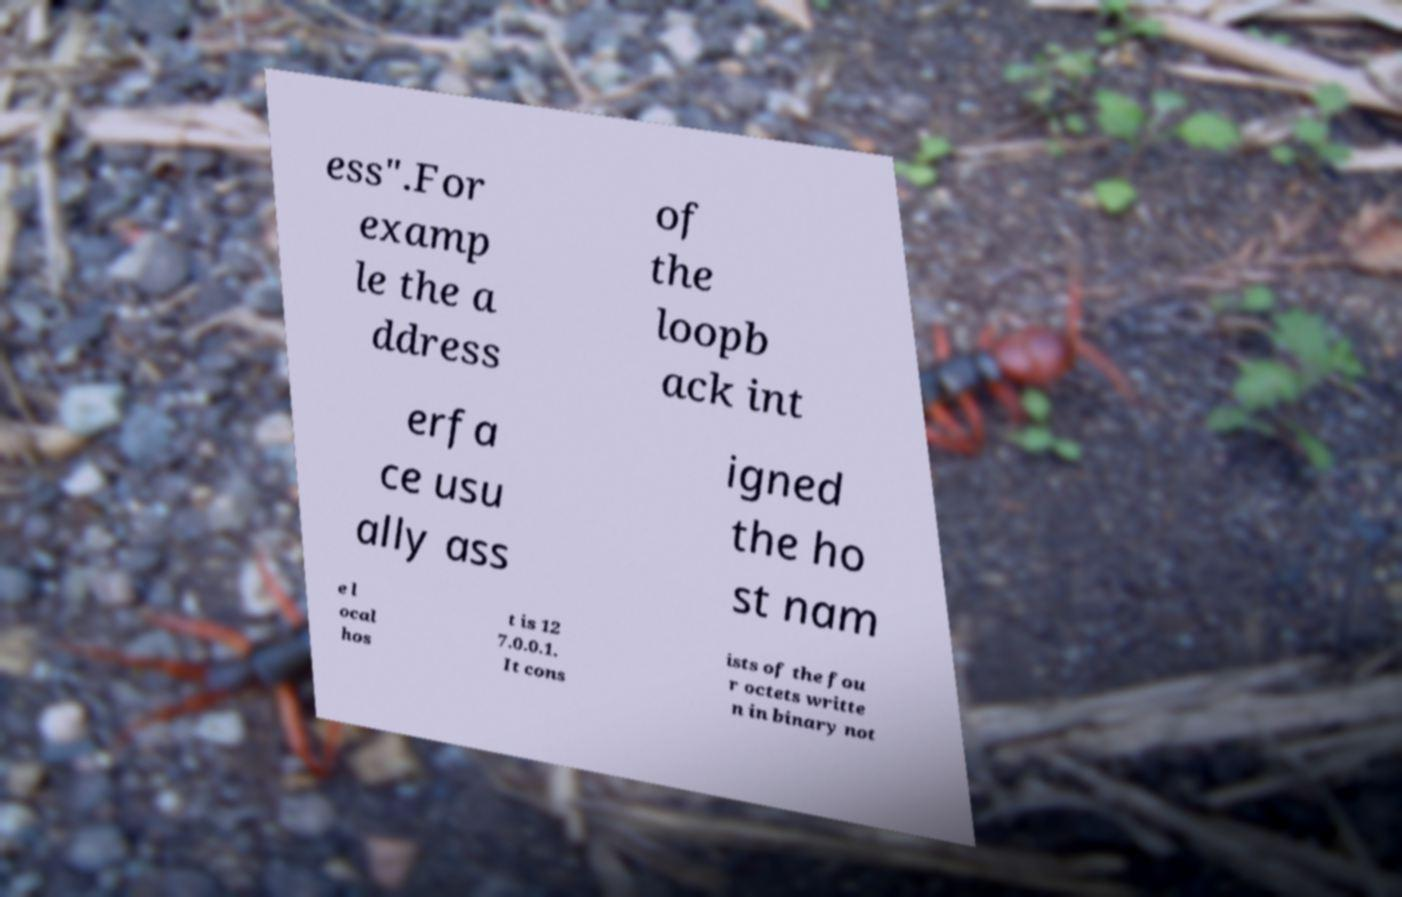Could you extract and type out the text from this image? ess".For examp le the a ddress of the loopb ack int erfa ce usu ally ass igned the ho st nam e l ocal hos t is 12 7.0.0.1. It cons ists of the fou r octets writte n in binary not 